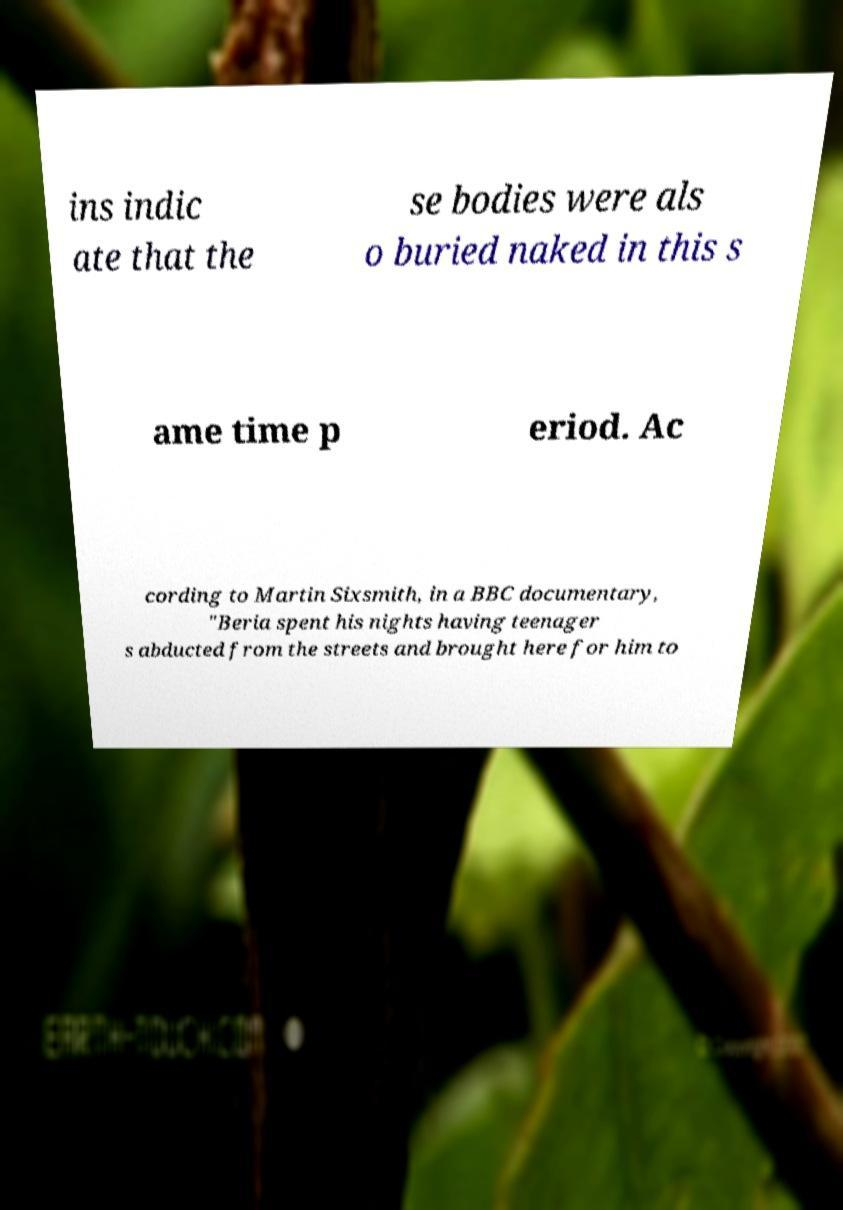What messages or text are displayed in this image? I need them in a readable, typed format. ins indic ate that the se bodies were als o buried naked in this s ame time p eriod. Ac cording to Martin Sixsmith, in a BBC documentary, "Beria spent his nights having teenager s abducted from the streets and brought here for him to 